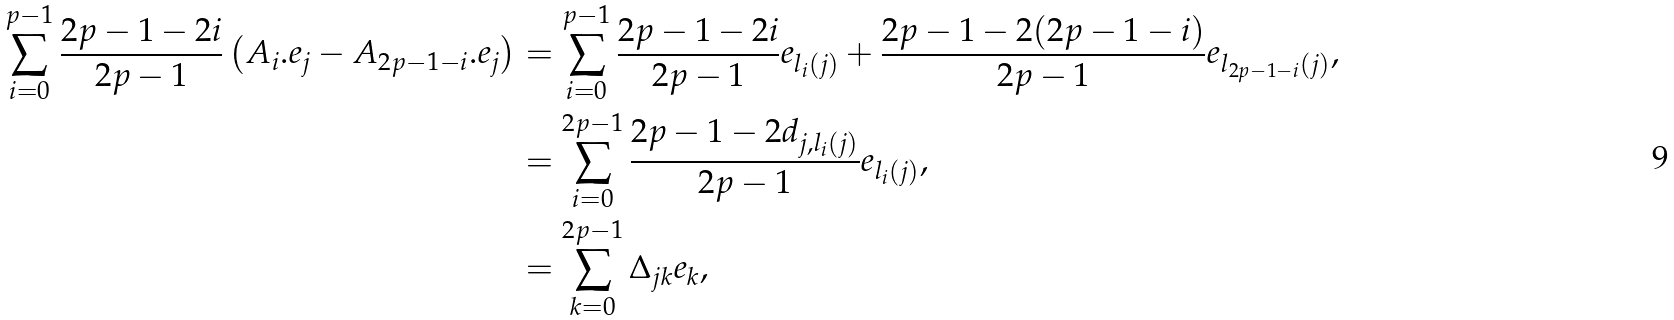Convert formula to latex. <formula><loc_0><loc_0><loc_500><loc_500>\sum _ { i = 0 } ^ { p - 1 } \frac { 2 p - 1 - 2 i } { 2 p - 1 } \left ( A _ { i } . e _ { j } - A _ { 2 p - 1 - i } . e _ { j } \right ) & = \sum _ { i = 0 } ^ { p - 1 } \frac { 2 p - 1 - 2 i } { 2 p - 1 } e _ { l _ { i } ( j ) } + \frac { 2 p - 1 - 2 ( 2 p - 1 - i ) } { 2 p - 1 } e _ { l _ { 2 p - 1 - i } ( j ) } , \\ & = \sum _ { i = 0 } ^ { 2 p - 1 } \frac { 2 p - 1 - 2 d _ { j , l _ { i } ( j ) } } { 2 p - 1 } e _ { l _ { i } ( j ) } , \\ & = \sum _ { k = 0 } ^ { 2 p - 1 } \Delta _ { j k } e _ { k } ,</formula> 